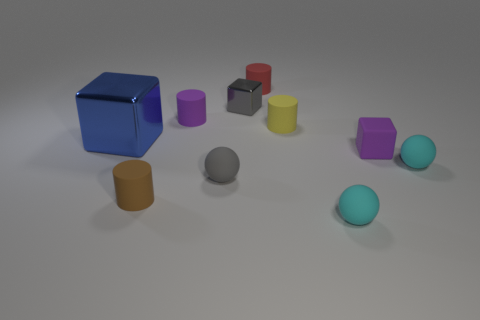Subtract all small brown cylinders. How many cylinders are left? 3 Subtract all purple cylinders. How many cylinders are left? 3 Subtract 1 cylinders. How many cylinders are left? 3 Subtract all green cylinders. Subtract all red spheres. How many cylinders are left? 4 Subtract all blocks. How many objects are left? 7 Add 9 tiny cyan cylinders. How many tiny cyan cylinders exist? 9 Subtract 2 cyan balls. How many objects are left? 8 Subtract all blue metal things. Subtract all small brown objects. How many objects are left? 8 Add 2 purple rubber cylinders. How many purple rubber cylinders are left? 3 